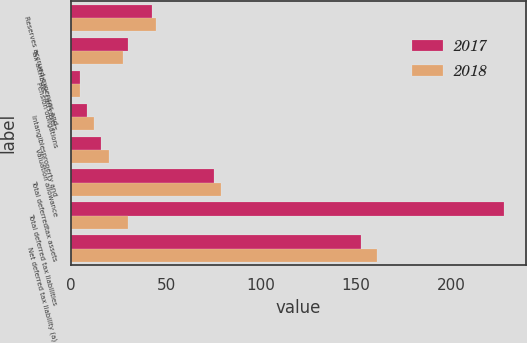Convert chart to OTSL. <chart><loc_0><loc_0><loc_500><loc_500><stacked_bar_chart><ecel><fcel>Reserves accrued expenses and<fcel>Tax attribute carryovers<fcel>Pension obligations<fcel>Intangiblesproperty and<fcel>Valuation allowance<fcel>Total deferredtax assets<fcel>Total deferred tax liabilities<fcel>Net deferred tax liability (a)<nl><fcel>2017<fcel>42.6<fcel>29.9<fcel>4.8<fcel>8.5<fcel>15.7<fcel>75.4<fcel>228<fcel>152.6<nl><fcel>2018<fcel>44.8<fcel>27.1<fcel>4.6<fcel>11.9<fcel>19.9<fcel>79.2<fcel>29.9<fcel>161.1<nl></chart> 